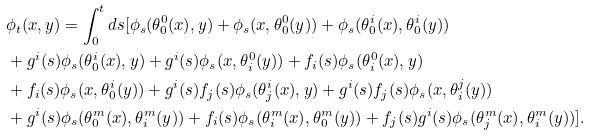<formula> <loc_0><loc_0><loc_500><loc_500>& \phi _ { t } ( x , y ) = \int _ { 0 } ^ { t } d s [ \phi _ { s } ( \theta ^ { 0 } _ { 0 } ( x ) , y ) + \phi _ { s } ( x , \theta ^ { 0 } _ { 0 } ( y ) ) + \phi _ { s } ( \theta ^ { i } _ { 0 } ( x ) , \theta ^ { i } _ { 0 } ( y ) ) \\ & + g ^ { i } ( s ) \phi _ { s } ( \theta ^ { i } _ { 0 } ( x ) , y ) + g ^ { i } ( s ) \phi _ { s } ( x , \theta ^ { 0 } _ { i } ( y ) ) + f _ { i } ( s ) \phi _ { s } ( \theta ^ { 0 } _ { i } ( x ) , y ) \\ & + f _ { i } ( s ) \phi _ { s } ( x , \theta ^ { i } _ { 0 } ( y ) ) + g ^ { i } ( s ) f _ { j } ( s ) \phi _ { s } ( \theta ^ { i } _ { j } ( x ) , y ) + g ^ { i } ( s ) f _ { j } ( s ) \phi _ { s } ( x , \theta ^ { j } _ { i } ( y ) ) \\ & + g ^ { i } ( s ) \phi _ { s } ( \theta ^ { m } _ { 0 } ( x ) , \theta ^ { m } _ { i } ( y ) ) + f _ { i } ( s ) \phi _ { s } ( \theta ^ { m } _ { i } ( x ) , \theta ^ { m } _ { 0 } ( y ) ) + f _ { j } ( s ) g ^ { i } ( s ) \phi _ { s } ( \theta ^ { m } _ { j } ( x ) , \theta ^ { m } _ { i } ( y ) ) ] .</formula> 